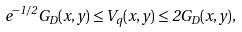<formula> <loc_0><loc_0><loc_500><loc_500>e ^ { - 1 / 2 } G _ { D } ( x , y ) \leq V _ { q } ( x , y ) \leq 2 G _ { D } ( x , y ) ,</formula> 